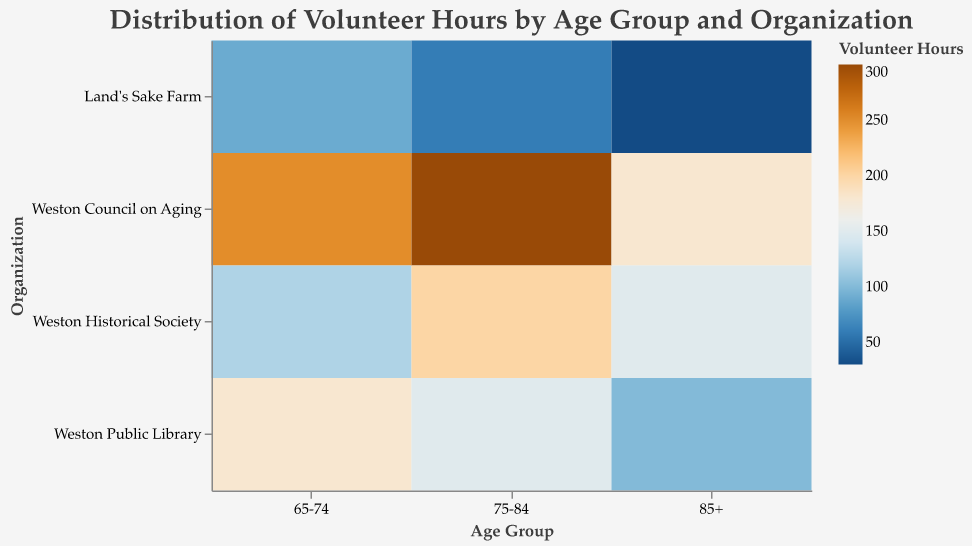What is the total number of volunteer hours for the Weston Council on Aging across all age groups? Sum the hours for Weston Council on Aging for each age group (250 + 300 + 180 = 730).
Answer: 730 Which age group contributes the most volunteer hours in the Weston Public Library? Compare the volunteer hours of the Weston Public Library for each age group (180 for 65-74, 150 for 75-84, and 100 for 85+). The age group 65-74 has the highest number of hours.
Answer: 65-74 Is there a certain age group that spends significantly fewer hours volunteering at Land's Sake Farm compared to the others? Compare the volunteer hours at Land's Sake Farm for each age group (90 for 65-74, 60 for 75-84, and 30 for 85+). The 85+ age group spends significantly fewer hours compared to the others.
Answer: 85+ How do the volunteer hours for Weston Historical Society change as age increases? Examine the volunteer hours for Weston Historical Society by age group (120 for 65-74, 200 for 75-84, and 150 for 85+). Hours peak at 75-84 and then decrease at 85+.
Answer: Increase, then decrease What is the most volunteered organization for the 85+ age group? Identify the organization with the highest volunteer hours for the 85+ age group (Weston Council on Aging with 180 hours).
Answer: Weston Council on Aging Which organization sees the highest volunteer hours from the 75-84 age group? Identify the organization with the highest volunteer hours for the 75-84 age group (Weston Council on Aging with 300 hours).
Answer: Weston Council on Aging What is the average number of volunteer hours across all organizations for the 65-74 age group? Add the volunteer hours of all organizations for 65-74 (250 + 180 + 120 + 90 = 640). Then, divide by the number of organizations (640 / 4).
Answer: 160 Compare the volunteer hours of Weston Historical Society between age groups 65-74 and 75-84. The volunteer hours for 65-74 is 120, and for 75-84 is 200. The 75-84 age group has more hours.
Answer: 75-84 has more hours If we add the volunteer hours at Land's Sake Farm for all age groups, what is the total? Sum the volunteer hours at Land's Sake Farm across all age groups (90 + 60 + 30).
Answer: 180 